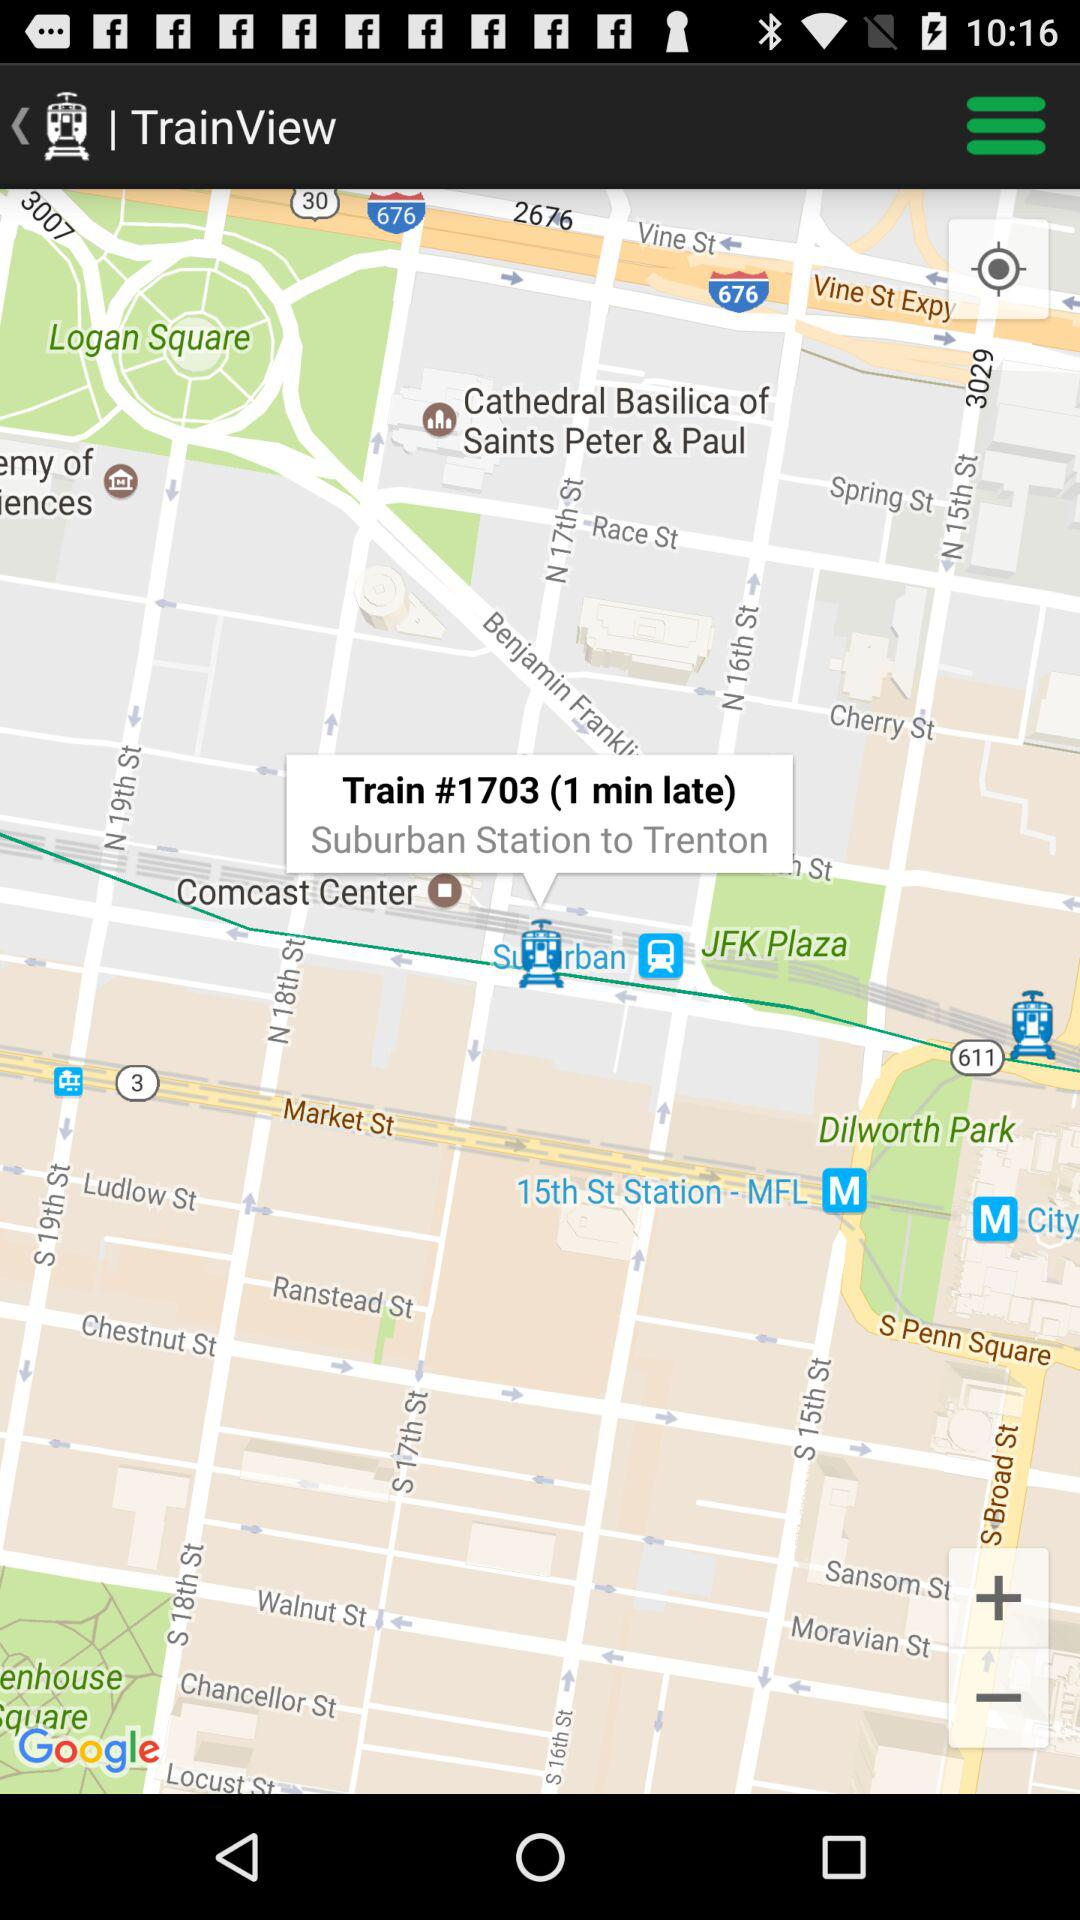How many minutes late is the train?
Answer the question using a single word or phrase. 1 